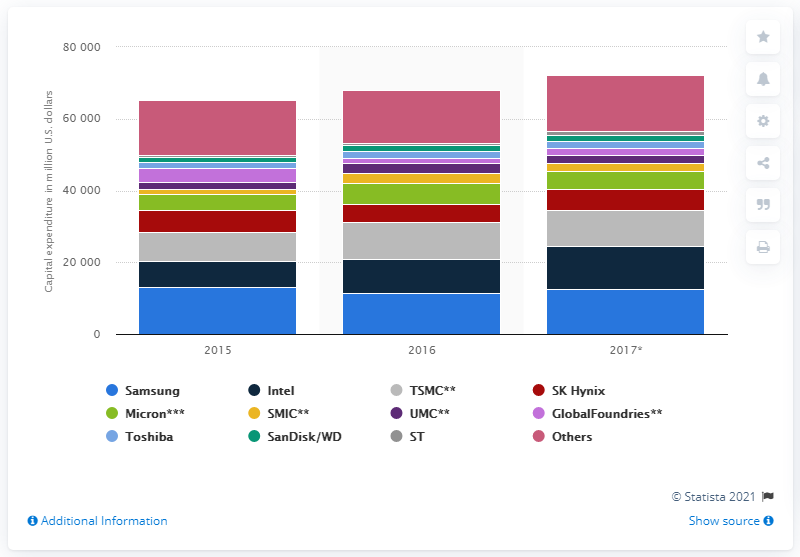Mention a couple of crucial points in this snapshot. In 2017, Samsung is expected to have a semiconductor capital expenditure budget of approximately $125 billion. 